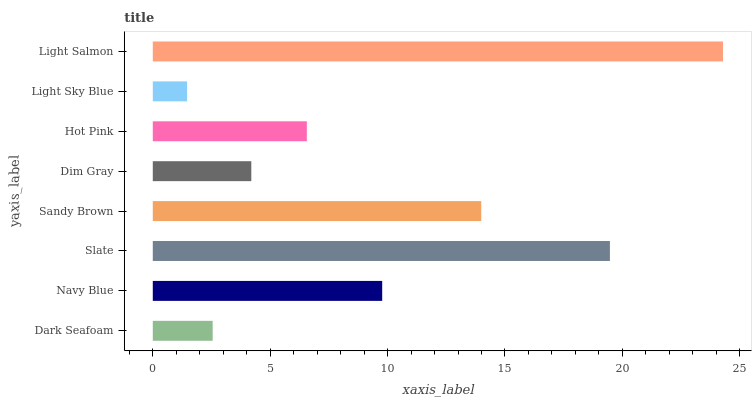Is Light Sky Blue the minimum?
Answer yes or no. Yes. Is Light Salmon the maximum?
Answer yes or no. Yes. Is Navy Blue the minimum?
Answer yes or no. No. Is Navy Blue the maximum?
Answer yes or no. No. Is Navy Blue greater than Dark Seafoam?
Answer yes or no. Yes. Is Dark Seafoam less than Navy Blue?
Answer yes or no. Yes. Is Dark Seafoam greater than Navy Blue?
Answer yes or no. No. Is Navy Blue less than Dark Seafoam?
Answer yes or no. No. Is Navy Blue the high median?
Answer yes or no. Yes. Is Hot Pink the low median?
Answer yes or no. Yes. Is Dim Gray the high median?
Answer yes or no. No. Is Navy Blue the low median?
Answer yes or no. No. 